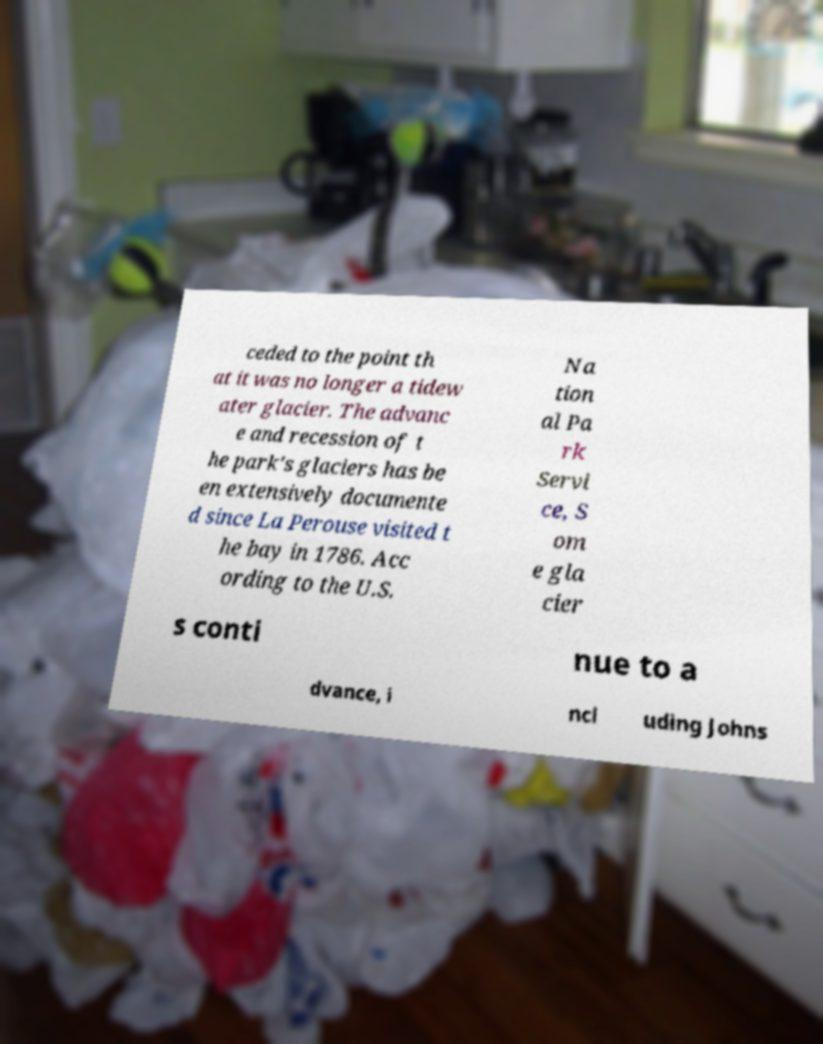Please read and relay the text visible in this image. What does it say? ceded to the point th at it was no longer a tidew ater glacier. The advanc e and recession of t he park's glaciers has be en extensively documente d since La Perouse visited t he bay in 1786. Acc ording to the U.S. Na tion al Pa rk Servi ce, S om e gla cier s conti nue to a dvance, i ncl uding Johns 